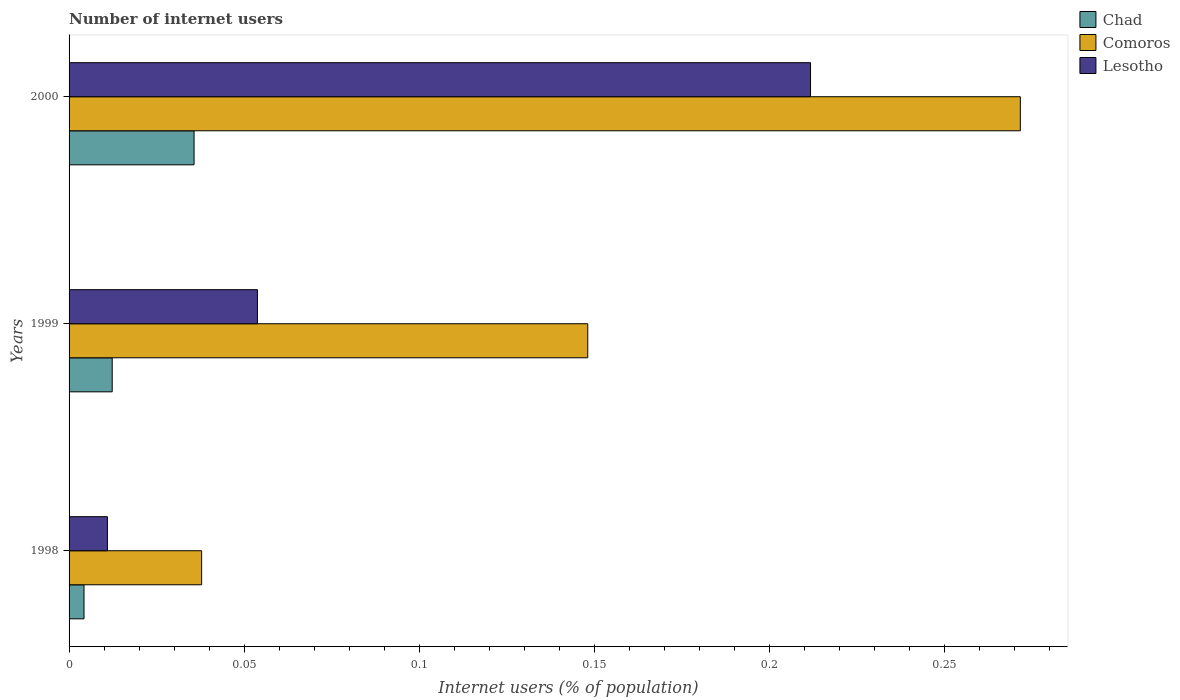How many different coloured bars are there?
Make the answer very short. 3. How many bars are there on the 1st tick from the bottom?
Provide a succinct answer. 3. In how many cases, is the number of bars for a given year not equal to the number of legend labels?
Ensure brevity in your answer.  0. What is the number of internet users in Chad in 2000?
Your answer should be very brief. 0.04. Across all years, what is the maximum number of internet users in Comoros?
Your answer should be very brief. 0.27. Across all years, what is the minimum number of internet users in Chad?
Offer a very short reply. 0. In which year was the number of internet users in Comoros maximum?
Provide a short and direct response. 2000. In which year was the number of internet users in Chad minimum?
Provide a short and direct response. 1998. What is the total number of internet users in Comoros in the graph?
Your answer should be very brief. 0.46. What is the difference between the number of internet users in Chad in 1998 and that in 1999?
Your response must be concise. -0.01. What is the difference between the number of internet users in Comoros in 2000 and the number of internet users in Chad in 1998?
Offer a very short reply. 0.27. What is the average number of internet users in Comoros per year?
Provide a succinct answer. 0.15. In the year 1999, what is the difference between the number of internet users in Lesotho and number of internet users in Comoros?
Offer a terse response. -0.09. What is the ratio of the number of internet users in Lesotho in 1998 to that in 1999?
Provide a short and direct response. 0.2. Is the number of internet users in Lesotho in 1998 less than that in 1999?
Offer a terse response. Yes. Is the difference between the number of internet users in Lesotho in 1999 and 2000 greater than the difference between the number of internet users in Comoros in 1999 and 2000?
Provide a succinct answer. No. What is the difference between the highest and the second highest number of internet users in Comoros?
Offer a terse response. 0.12. What is the difference between the highest and the lowest number of internet users in Chad?
Your answer should be compact. 0.03. In how many years, is the number of internet users in Chad greater than the average number of internet users in Chad taken over all years?
Offer a very short reply. 1. What does the 3rd bar from the top in 1998 represents?
Ensure brevity in your answer.  Chad. What does the 1st bar from the bottom in 1999 represents?
Provide a succinct answer. Chad. Is it the case that in every year, the sum of the number of internet users in Chad and number of internet users in Comoros is greater than the number of internet users in Lesotho?
Your answer should be very brief. Yes. How many bars are there?
Provide a succinct answer. 9. Are the values on the major ticks of X-axis written in scientific E-notation?
Offer a very short reply. No. Does the graph contain grids?
Ensure brevity in your answer.  No. Where does the legend appear in the graph?
Give a very brief answer. Top right. What is the title of the graph?
Your answer should be compact. Number of internet users. Does "Grenada" appear as one of the legend labels in the graph?
Offer a terse response. No. What is the label or title of the X-axis?
Your answer should be very brief. Internet users (% of population). What is the label or title of the Y-axis?
Keep it short and to the point. Years. What is the Internet users (% of population) of Chad in 1998?
Provide a succinct answer. 0. What is the Internet users (% of population) in Comoros in 1998?
Your answer should be compact. 0.04. What is the Internet users (% of population) of Lesotho in 1998?
Make the answer very short. 0.01. What is the Internet users (% of population) in Chad in 1999?
Offer a terse response. 0.01. What is the Internet users (% of population) of Comoros in 1999?
Your response must be concise. 0.15. What is the Internet users (% of population) in Lesotho in 1999?
Provide a succinct answer. 0.05. What is the Internet users (% of population) in Chad in 2000?
Keep it short and to the point. 0.04. What is the Internet users (% of population) in Comoros in 2000?
Keep it short and to the point. 0.27. What is the Internet users (% of population) in Lesotho in 2000?
Your answer should be very brief. 0.21. Across all years, what is the maximum Internet users (% of population) in Chad?
Make the answer very short. 0.04. Across all years, what is the maximum Internet users (% of population) in Comoros?
Offer a terse response. 0.27. Across all years, what is the maximum Internet users (% of population) in Lesotho?
Provide a short and direct response. 0.21. Across all years, what is the minimum Internet users (% of population) of Chad?
Offer a terse response. 0. Across all years, what is the minimum Internet users (% of population) of Comoros?
Your answer should be compact. 0.04. Across all years, what is the minimum Internet users (% of population) of Lesotho?
Ensure brevity in your answer.  0.01. What is the total Internet users (% of population) in Chad in the graph?
Your response must be concise. 0.05. What is the total Internet users (% of population) in Comoros in the graph?
Offer a very short reply. 0.46. What is the total Internet users (% of population) of Lesotho in the graph?
Provide a succinct answer. 0.28. What is the difference between the Internet users (% of population) of Chad in 1998 and that in 1999?
Your answer should be very brief. -0.01. What is the difference between the Internet users (% of population) of Comoros in 1998 and that in 1999?
Ensure brevity in your answer.  -0.11. What is the difference between the Internet users (% of population) of Lesotho in 1998 and that in 1999?
Offer a terse response. -0.04. What is the difference between the Internet users (% of population) in Chad in 1998 and that in 2000?
Give a very brief answer. -0.03. What is the difference between the Internet users (% of population) in Comoros in 1998 and that in 2000?
Keep it short and to the point. -0.23. What is the difference between the Internet users (% of population) of Lesotho in 1998 and that in 2000?
Keep it short and to the point. -0.2. What is the difference between the Internet users (% of population) of Chad in 1999 and that in 2000?
Your answer should be very brief. -0.02. What is the difference between the Internet users (% of population) of Comoros in 1999 and that in 2000?
Keep it short and to the point. -0.12. What is the difference between the Internet users (% of population) of Lesotho in 1999 and that in 2000?
Provide a succinct answer. -0.16. What is the difference between the Internet users (% of population) of Chad in 1998 and the Internet users (% of population) of Comoros in 1999?
Ensure brevity in your answer.  -0.14. What is the difference between the Internet users (% of population) in Chad in 1998 and the Internet users (% of population) in Lesotho in 1999?
Offer a very short reply. -0.05. What is the difference between the Internet users (% of population) in Comoros in 1998 and the Internet users (% of population) in Lesotho in 1999?
Your response must be concise. -0.02. What is the difference between the Internet users (% of population) in Chad in 1998 and the Internet users (% of population) in Comoros in 2000?
Your response must be concise. -0.27. What is the difference between the Internet users (% of population) of Chad in 1998 and the Internet users (% of population) of Lesotho in 2000?
Keep it short and to the point. -0.21. What is the difference between the Internet users (% of population) of Comoros in 1998 and the Internet users (% of population) of Lesotho in 2000?
Give a very brief answer. -0.17. What is the difference between the Internet users (% of population) of Chad in 1999 and the Internet users (% of population) of Comoros in 2000?
Keep it short and to the point. -0.26. What is the difference between the Internet users (% of population) in Chad in 1999 and the Internet users (% of population) in Lesotho in 2000?
Your answer should be very brief. -0.2. What is the difference between the Internet users (% of population) in Comoros in 1999 and the Internet users (% of population) in Lesotho in 2000?
Make the answer very short. -0.06. What is the average Internet users (% of population) in Chad per year?
Keep it short and to the point. 0.02. What is the average Internet users (% of population) of Comoros per year?
Ensure brevity in your answer.  0.15. What is the average Internet users (% of population) of Lesotho per year?
Your answer should be very brief. 0.09. In the year 1998, what is the difference between the Internet users (% of population) in Chad and Internet users (% of population) in Comoros?
Your answer should be compact. -0.03. In the year 1998, what is the difference between the Internet users (% of population) in Chad and Internet users (% of population) in Lesotho?
Your response must be concise. -0.01. In the year 1998, what is the difference between the Internet users (% of population) in Comoros and Internet users (% of population) in Lesotho?
Make the answer very short. 0.03. In the year 1999, what is the difference between the Internet users (% of population) of Chad and Internet users (% of population) of Comoros?
Provide a succinct answer. -0.14. In the year 1999, what is the difference between the Internet users (% of population) in Chad and Internet users (% of population) in Lesotho?
Your answer should be very brief. -0.04. In the year 1999, what is the difference between the Internet users (% of population) in Comoros and Internet users (% of population) in Lesotho?
Give a very brief answer. 0.09. In the year 2000, what is the difference between the Internet users (% of population) of Chad and Internet users (% of population) of Comoros?
Offer a very short reply. -0.24. In the year 2000, what is the difference between the Internet users (% of population) of Chad and Internet users (% of population) of Lesotho?
Keep it short and to the point. -0.18. In the year 2000, what is the difference between the Internet users (% of population) of Comoros and Internet users (% of population) of Lesotho?
Give a very brief answer. 0.06. What is the ratio of the Internet users (% of population) in Chad in 1998 to that in 1999?
Your answer should be compact. 0.35. What is the ratio of the Internet users (% of population) in Comoros in 1998 to that in 1999?
Offer a very short reply. 0.26. What is the ratio of the Internet users (% of population) in Lesotho in 1998 to that in 1999?
Offer a very short reply. 0.2. What is the ratio of the Internet users (% of population) in Chad in 1998 to that in 2000?
Offer a terse response. 0.12. What is the ratio of the Internet users (% of population) of Comoros in 1998 to that in 2000?
Your response must be concise. 0.14. What is the ratio of the Internet users (% of population) in Lesotho in 1998 to that in 2000?
Your response must be concise. 0.05. What is the ratio of the Internet users (% of population) in Chad in 1999 to that in 2000?
Provide a short and direct response. 0.35. What is the ratio of the Internet users (% of population) in Comoros in 1999 to that in 2000?
Ensure brevity in your answer.  0.55. What is the ratio of the Internet users (% of population) of Lesotho in 1999 to that in 2000?
Your response must be concise. 0.25. What is the difference between the highest and the second highest Internet users (% of population) of Chad?
Your answer should be compact. 0.02. What is the difference between the highest and the second highest Internet users (% of population) in Comoros?
Keep it short and to the point. 0.12. What is the difference between the highest and the second highest Internet users (% of population) in Lesotho?
Provide a short and direct response. 0.16. What is the difference between the highest and the lowest Internet users (% of population) in Chad?
Your answer should be very brief. 0.03. What is the difference between the highest and the lowest Internet users (% of population) in Comoros?
Provide a succinct answer. 0.23. What is the difference between the highest and the lowest Internet users (% of population) of Lesotho?
Provide a short and direct response. 0.2. 